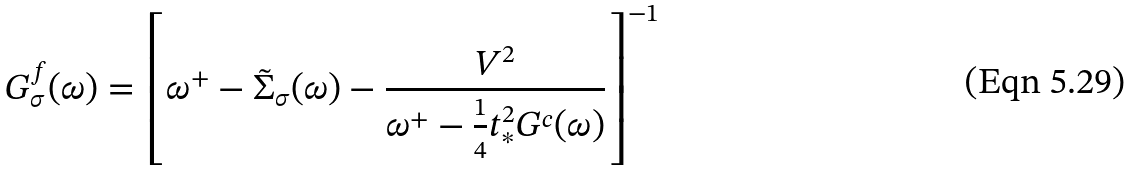Convert formula to latex. <formula><loc_0><loc_0><loc_500><loc_500>G _ { \sigma } ^ { f } ( \omega ) = \left [ \omega ^ { + } - \tilde { \Sigma } _ { \sigma } ( \omega ) - \frac { V ^ { 2 } } { \omega ^ { + } - \frac { 1 } { 4 } t _ { \ast } ^ { 2 } G ^ { c } ( \omega ) } \right ] ^ { - 1 }</formula> 